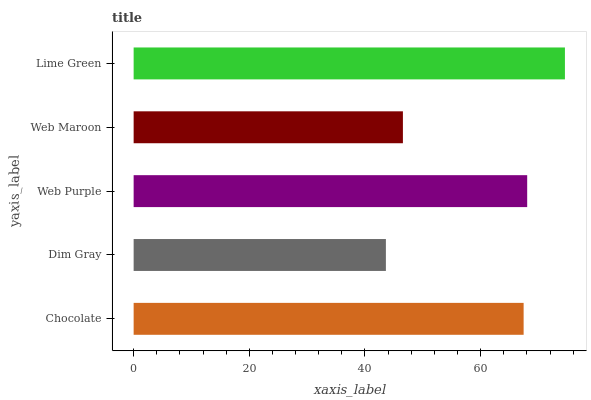Is Dim Gray the minimum?
Answer yes or no. Yes. Is Lime Green the maximum?
Answer yes or no. Yes. Is Web Purple the minimum?
Answer yes or no. No. Is Web Purple the maximum?
Answer yes or no. No. Is Web Purple greater than Dim Gray?
Answer yes or no. Yes. Is Dim Gray less than Web Purple?
Answer yes or no. Yes. Is Dim Gray greater than Web Purple?
Answer yes or no. No. Is Web Purple less than Dim Gray?
Answer yes or no. No. Is Chocolate the high median?
Answer yes or no. Yes. Is Chocolate the low median?
Answer yes or no. Yes. Is Web Purple the high median?
Answer yes or no. No. Is Web Maroon the low median?
Answer yes or no. No. 